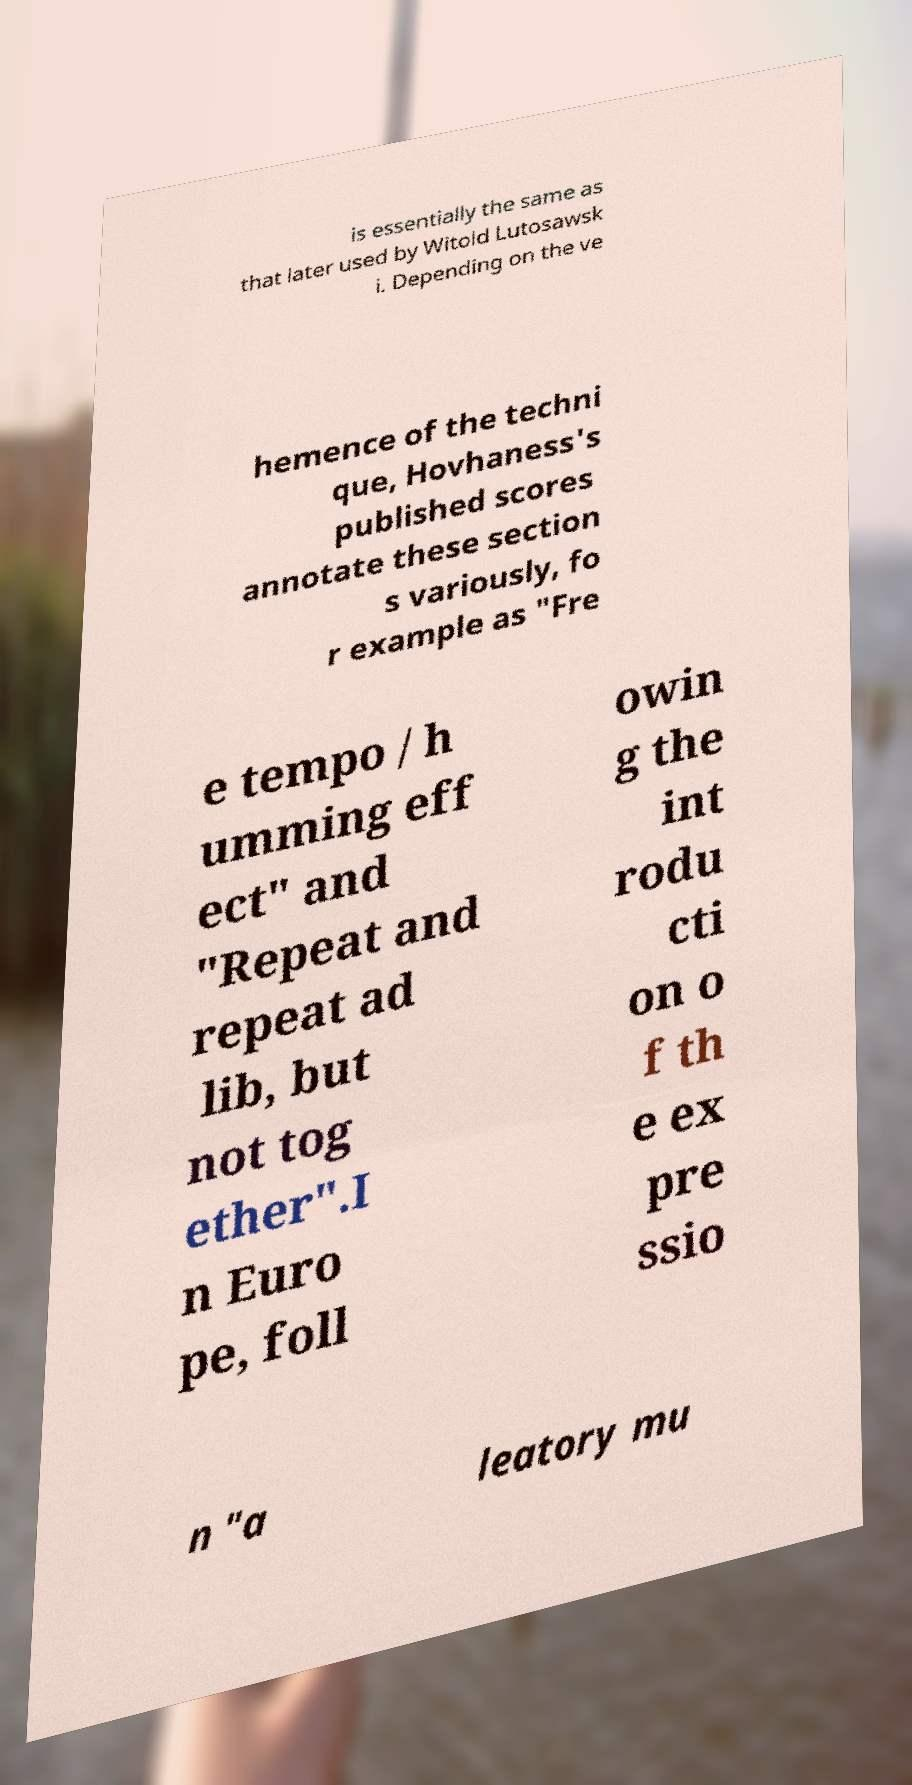Please read and relay the text visible in this image. What does it say? is essentially the same as that later used by Witold Lutosawsk i. Depending on the ve hemence of the techni que, Hovhaness's published scores annotate these section s variously, fo r example as "Fre e tempo / h umming eff ect" and "Repeat and repeat ad lib, but not tog ether".I n Euro pe, foll owin g the int rodu cti on o f th e ex pre ssio n "a leatory mu 